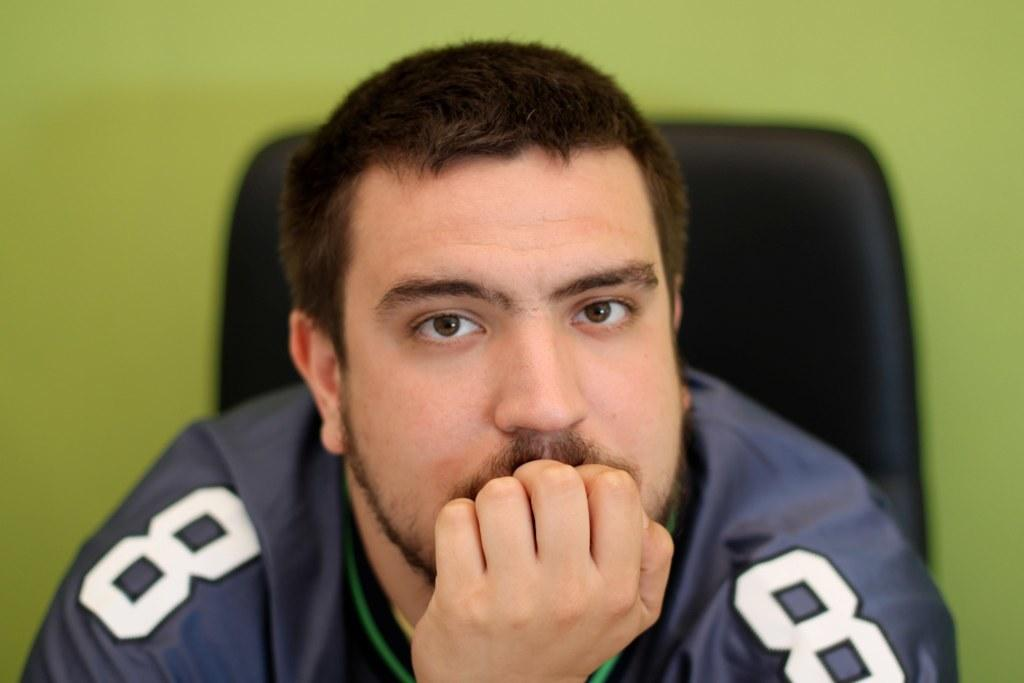<image>
Render a clear and concise summary of the photo. A man with the number 8 on each shoulder has his hand to his mouth. 